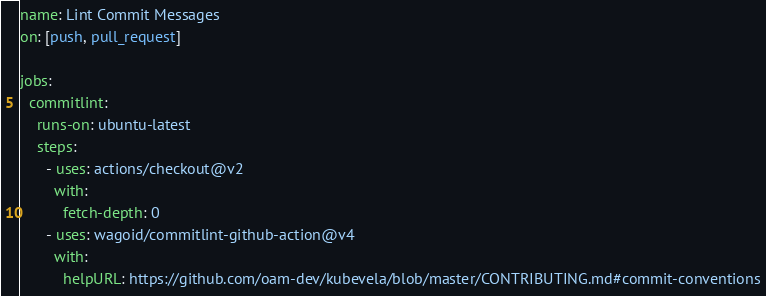<code> <loc_0><loc_0><loc_500><loc_500><_YAML_>name: Lint Commit Messages
on: [push, pull_request]

jobs:
  commitlint:
    runs-on: ubuntu-latest
    steps:
      - uses: actions/checkout@v2
        with:
          fetch-depth: 0
      - uses: wagoid/commitlint-github-action@v4
        with:
          helpURL: https://github.com/oam-dev/kubevela/blob/master/CONTRIBUTING.md#commit-conventions</code> 